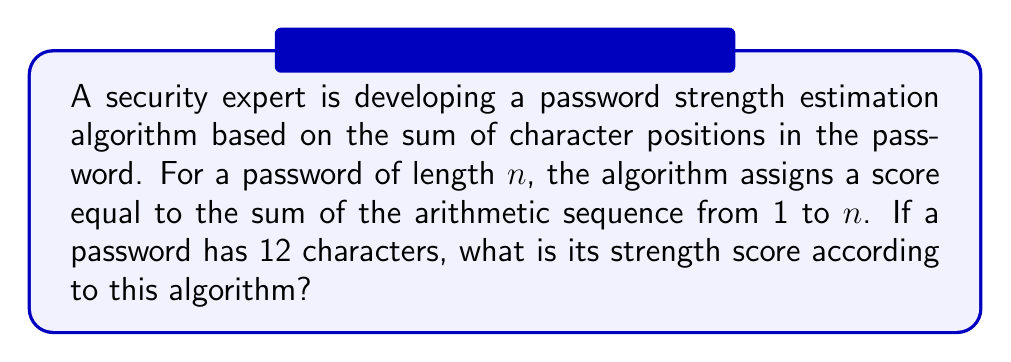Teach me how to tackle this problem. To solve this problem, we need to find the sum of the arithmetic sequence from 1 to 12. Let's approach this step-by-step:

1. Identify the sequence:
   The sequence is 1, 2, 3, ..., 12

2. Use the formula for the sum of an arithmetic sequence:
   $$S_n = \frac{n(a_1 + a_n)}{2}$$
   Where:
   $S_n$ is the sum of the sequence
   $n$ is the number of terms
   $a_1$ is the first term
   $a_n$ is the last term

3. Plug in the values:
   $n = 12$ (number of characters in the password)
   $a_1 = 1$ (first term)
   $a_n = a_{12} = 12$ (last term)

4. Calculate:
   $$S_{12} = \frac{12(1 + 12)}{2}$$
   $$S_{12} = \frac{12(13)}{2}$$
   $$S_{12} = \frac{156}{2}$$
   $$S_{12} = 78$$

Therefore, the strength score for a 12-character password according to this algorithm is 78.
Answer: 78 